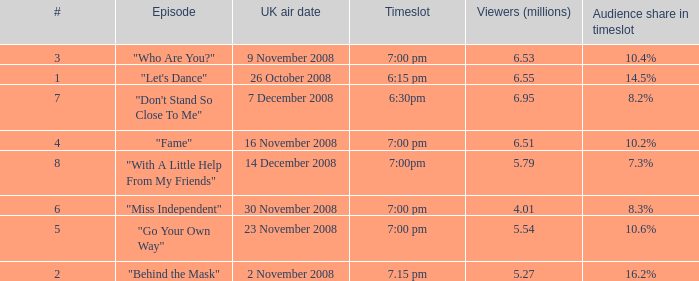Name the uk air date for audience share in timeslot in 7.3% 14 December 2008. 